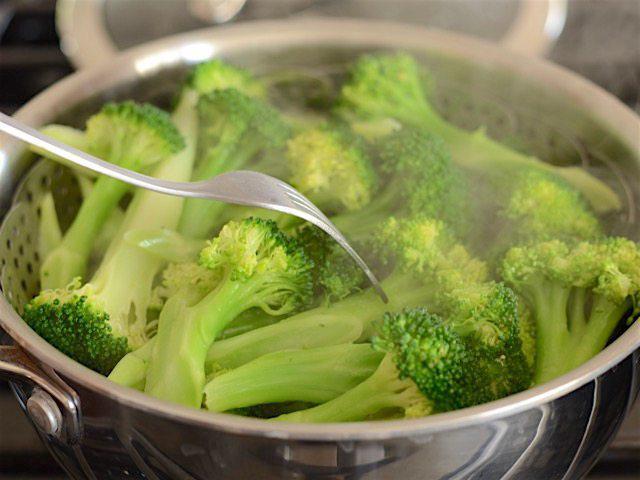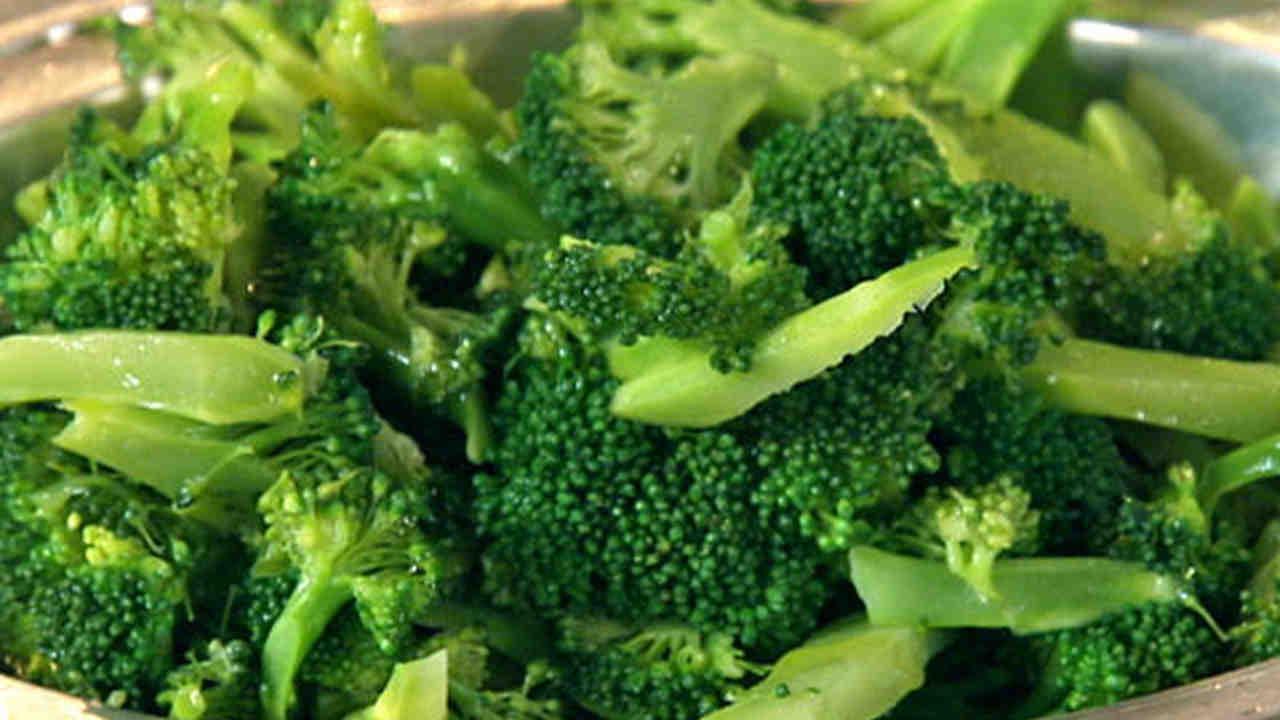The first image is the image on the left, the second image is the image on the right. For the images shown, is this caption "The left and right image contains the same number of porcelain plates holding broccoli." true? Answer yes or no. No. 